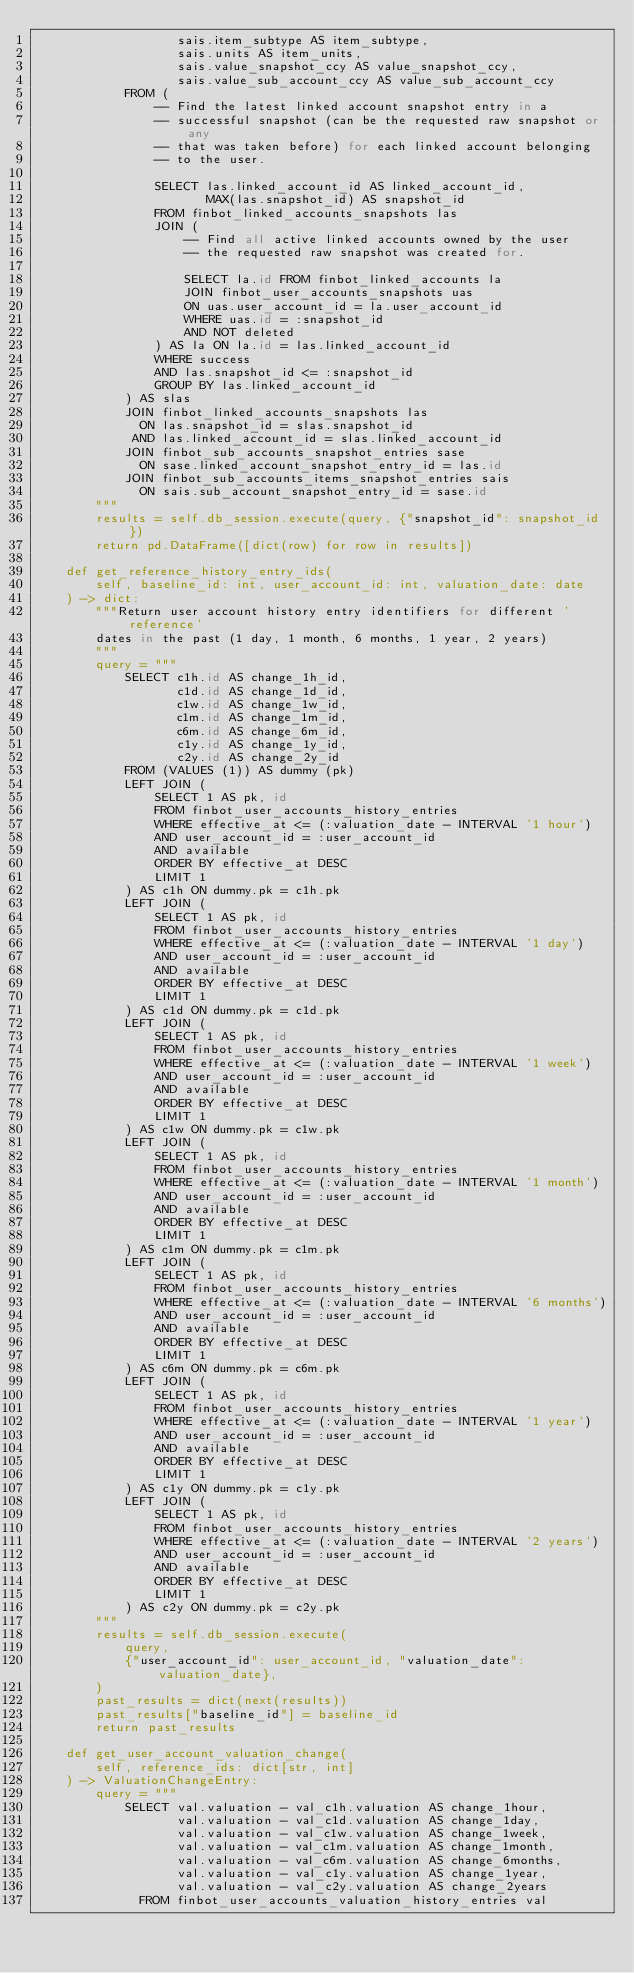<code> <loc_0><loc_0><loc_500><loc_500><_Python_>                   sais.item_subtype AS item_subtype,
                   sais.units AS item_units,
                   sais.value_snapshot_ccy AS value_snapshot_ccy,
                   sais.value_sub_account_ccy AS value_sub_account_ccy
            FROM (
                -- Find the latest linked account snapshot entry in a
                -- successful snapshot (can be the requested raw snapshot or any
                -- that was taken before) for each linked account belonging
                -- to the user.

                SELECT las.linked_account_id AS linked_account_id,
                       MAX(las.snapshot_id) AS snapshot_id
                FROM finbot_linked_accounts_snapshots las
                JOIN (
                    -- Find all active linked accounts owned by the user
                    -- the requested raw snapshot was created for.

                    SELECT la.id FROM finbot_linked_accounts la
                    JOIN finbot_user_accounts_snapshots uas
                    ON uas.user_account_id = la.user_account_id
                    WHERE uas.id = :snapshot_id
                    AND NOT deleted
                ) AS la ON la.id = las.linked_account_id
                WHERE success
                AND las.snapshot_id <= :snapshot_id
                GROUP BY las.linked_account_id
            ) AS slas
            JOIN finbot_linked_accounts_snapshots las
              ON las.snapshot_id = slas.snapshot_id
             AND las.linked_account_id = slas.linked_account_id
            JOIN finbot_sub_accounts_snapshot_entries sase
              ON sase.linked_account_snapshot_entry_id = las.id
            JOIN finbot_sub_accounts_items_snapshot_entries sais
              ON sais.sub_account_snapshot_entry_id = sase.id
        """
        results = self.db_session.execute(query, {"snapshot_id": snapshot_id})
        return pd.DataFrame([dict(row) for row in results])

    def get_reference_history_entry_ids(
        self, baseline_id: int, user_account_id: int, valuation_date: date
    ) -> dict:
        """Return user account history entry identifiers for different 'reference'
        dates in the past (1 day, 1 month, 6 months, 1 year, 2 years)
        """
        query = """
            SELECT c1h.id AS change_1h_id,
                   c1d.id AS change_1d_id,
                   c1w.id AS change_1w_id,
                   c1m.id AS change_1m_id,
                   c6m.id AS change_6m_id,
                   c1y.id AS change_1y_id,
                   c2y.id AS change_2y_id
            FROM (VALUES (1)) AS dummy (pk)
            LEFT JOIN (
                SELECT 1 AS pk, id
                FROM finbot_user_accounts_history_entries
                WHERE effective_at <= (:valuation_date - INTERVAL '1 hour')
                AND user_account_id = :user_account_id
                AND available
                ORDER BY effective_at DESC
                LIMIT 1
            ) AS c1h ON dummy.pk = c1h.pk
            LEFT JOIN (
                SELECT 1 AS pk, id
                FROM finbot_user_accounts_history_entries
                WHERE effective_at <= (:valuation_date - INTERVAL '1 day')
                AND user_account_id = :user_account_id
                AND available
                ORDER BY effective_at DESC
                LIMIT 1
            ) AS c1d ON dummy.pk = c1d.pk
            LEFT JOIN (
                SELECT 1 AS pk, id
                FROM finbot_user_accounts_history_entries
                WHERE effective_at <= (:valuation_date - INTERVAL '1 week')
                AND user_account_id = :user_account_id
                AND available
                ORDER BY effective_at DESC
                LIMIT 1
            ) AS c1w ON dummy.pk = c1w.pk
            LEFT JOIN (
                SELECT 1 AS pk, id
                FROM finbot_user_accounts_history_entries
                WHERE effective_at <= (:valuation_date - INTERVAL '1 month')
                AND user_account_id = :user_account_id
                AND available
                ORDER BY effective_at DESC
                LIMIT 1
            ) AS c1m ON dummy.pk = c1m.pk
            LEFT JOIN (
                SELECT 1 AS pk, id
                FROM finbot_user_accounts_history_entries
                WHERE effective_at <= (:valuation_date - INTERVAL '6 months')
                AND user_account_id = :user_account_id
                AND available
                ORDER BY effective_at DESC
                LIMIT 1
            ) AS c6m ON dummy.pk = c6m.pk
            LEFT JOIN (
                SELECT 1 AS pk, id
                FROM finbot_user_accounts_history_entries
                WHERE effective_at <= (:valuation_date - INTERVAL '1 year')
                AND user_account_id = :user_account_id
                AND available
                ORDER BY effective_at DESC
                LIMIT 1
            ) AS c1y ON dummy.pk = c1y.pk
            LEFT JOIN (
                SELECT 1 AS pk, id
                FROM finbot_user_accounts_history_entries
                WHERE effective_at <= (:valuation_date - INTERVAL '2 years')
                AND user_account_id = :user_account_id
                AND available
                ORDER BY effective_at DESC
                LIMIT 1
            ) AS c2y ON dummy.pk = c2y.pk
        """
        results = self.db_session.execute(
            query,
            {"user_account_id": user_account_id, "valuation_date": valuation_date},
        )
        past_results = dict(next(results))
        past_results["baseline_id"] = baseline_id
        return past_results

    def get_user_account_valuation_change(
        self, reference_ids: dict[str, int]
    ) -> ValuationChangeEntry:
        query = """
            SELECT val.valuation - val_c1h.valuation AS change_1hour,
                   val.valuation - val_c1d.valuation AS change_1day,
                   val.valuation - val_c1w.valuation AS change_1week,
                   val.valuation - val_c1m.valuation AS change_1month,
                   val.valuation - val_c6m.valuation AS change_6months,
                   val.valuation - val_c1y.valuation AS change_1year,
                   val.valuation - val_c2y.valuation AS change_2years
              FROM finbot_user_accounts_valuation_history_entries val</code> 